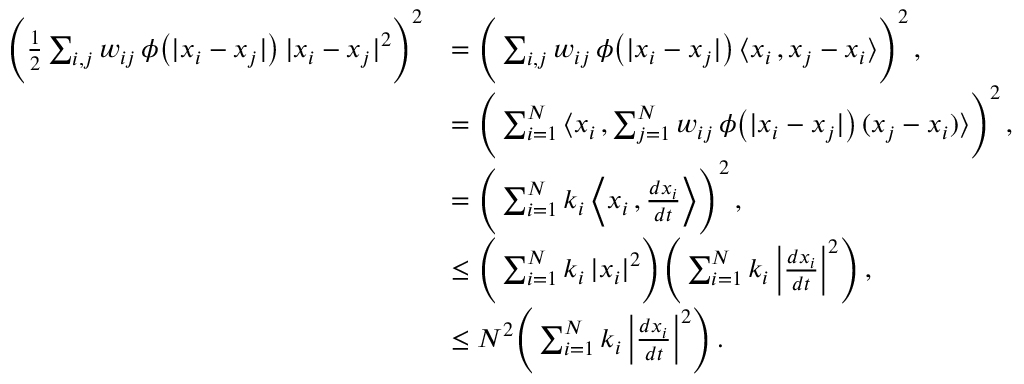<formula> <loc_0><loc_0><loc_500><loc_500>\begin{array} { r l } { \left ( \frac { 1 } { 2 } \sum _ { i , j } w _ { i j } \, \phi \left ( | x _ { i } - x _ { j } | \right ) \, | x _ { i } - x _ { j } | ^ { 2 } \right ) ^ { 2 } } & { = \left ( \sum _ { i , j } w _ { i j } \, \phi \left ( | x _ { i } - x _ { j } | \right ) \, \langle x _ { i } \, , x _ { j } - x _ { i } \rangle \right ) ^ { 2 } \, , } \\ & { = \left ( \sum _ { i = 1 } ^ { N } \left \langle x _ { i } \, , \sum _ { j = 1 } ^ { N } w _ { i j } \, \phi \left ( | x _ { i } - x _ { j } | \right ) \, ( x _ { j } - x _ { i } ) \right \rangle \right ) ^ { 2 } \, , } \\ & { = \left ( \sum _ { i = 1 } ^ { N } k _ { i } \, \left \langle x _ { i } \, , \frac { d x _ { i } } { d t } \right \rangle \right ) ^ { 2 } \, , } \\ & { \leq \left ( \sum _ { i = 1 } ^ { N } k _ { i } \, | x _ { i } | ^ { 2 } \right ) \left ( \sum _ { i = 1 } ^ { N } k _ { i } \, \left | \frac { d x _ { i } } { d t } \right | ^ { 2 } \right ) \, , } \\ & { \leq N ^ { 2 } \left ( \sum _ { i = 1 } ^ { N } k _ { i } \, \left | \frac { d x _ { i } } { d t } \right | ^ { 2 } \right ) \, . } \end{array}</formula> 